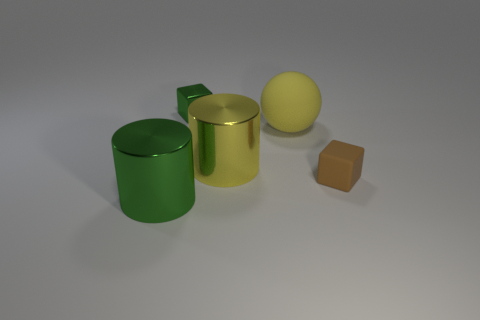Is there any other thing that has the same material as the large green cylinder? Yes, the yellow sphere appears to have a similar reflective surface indicating that it could be made of a material like the large green cylinder, which seems to be a kind of polished metal. 